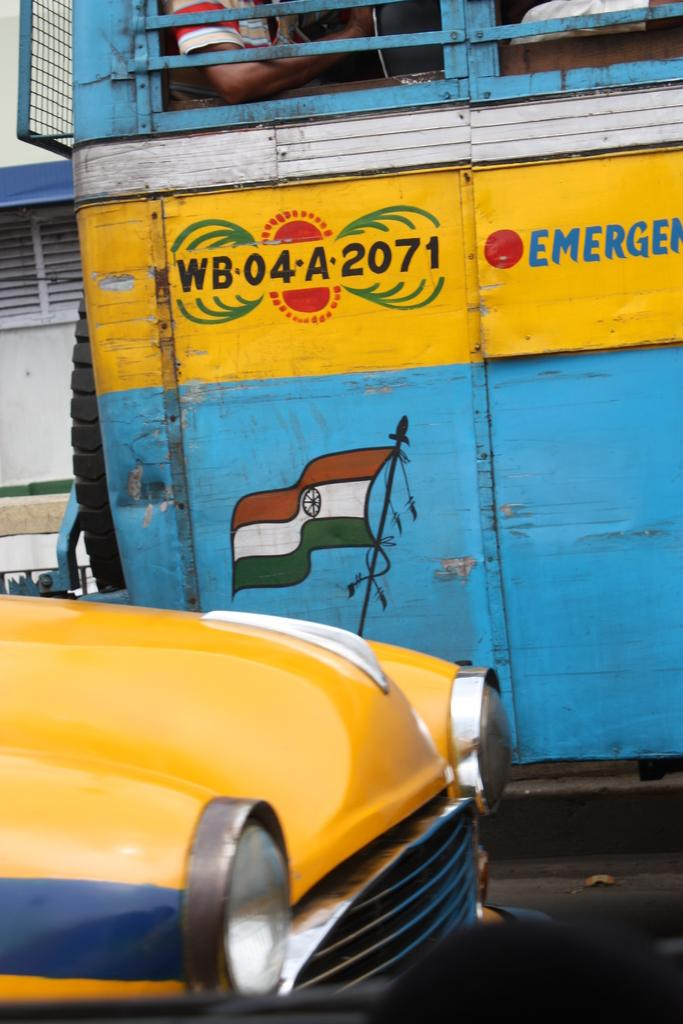What can be seen on the left side of the image? There is a car on the left side of the image. What else is visible in the image besides the car? There is some text visible in the image, a flag, people visible in a bus, and a building in the background. What might the text be communicating in the image? It is not possible to determine the exact message of the text without more context, but it is present in the image. What is the location of the flag in the image? The flag is in the image, but its exact location is not specified in the provided facts. What type of leather is being used to make the sandwiches in the image? There is no leather or sandwiches present in the image. How does the sand affect the visibility of the people in the bus in the image? There is no sand present in the image, so it does not affect the visibility of the people in the bus. 